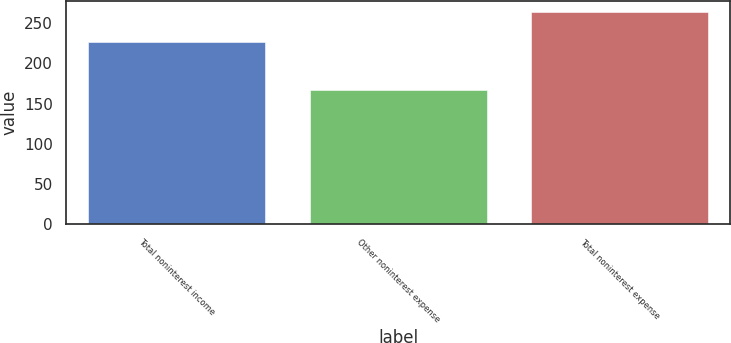Convert chart. <chart><loc_0><loc_0><loc_500><loc_500><bar_chart><fcel>Total noninterest income<fcel>Other noninterest expense<fcel>Total noninterest expense<nl><fcel>227<fcel>167<fcel>264<nl></chart> 